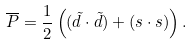<formula> <loc_0><loc_0><loc_500><loc_500>\overline { P } = \frac { 1 } { 2 } \left ( ( \tilde { d } \cdot \tilde { d } ) + ( s \cdot s ) \right ) .</formula> 